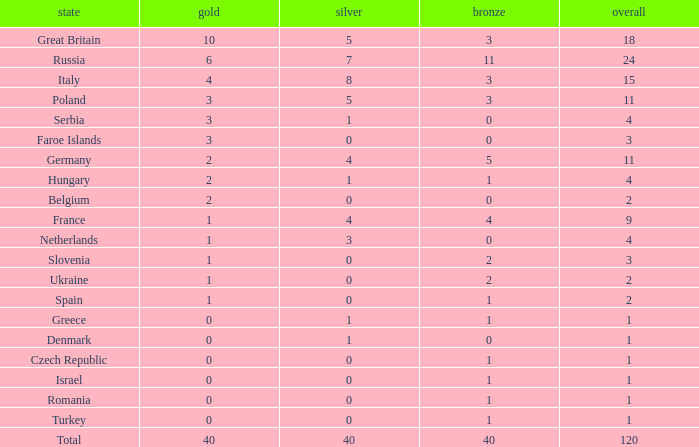What is the average Gold entry for the Netherlands that also has a Bronze entry that is greater than 0? None. 